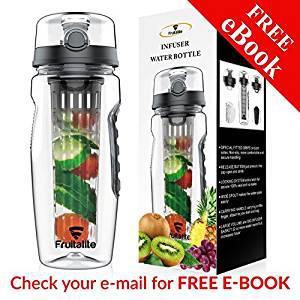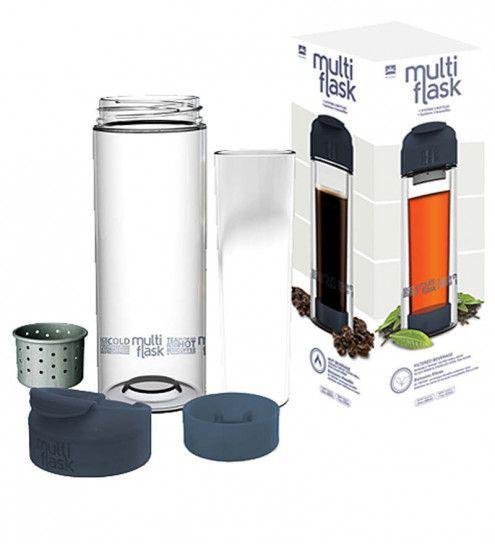The first image is the image on the left, the second image is the image on the right. For the images displayed, is the sentence "An image shows three water bottles posed next to fruits." factually correct? Answer yes or no. No. The first image is the image on the left, the second image is the image on the right. Assess this claim about the two images: "Three clear containers stand in a line in one of the images.". Correct or not? Answer yes or no. No. 